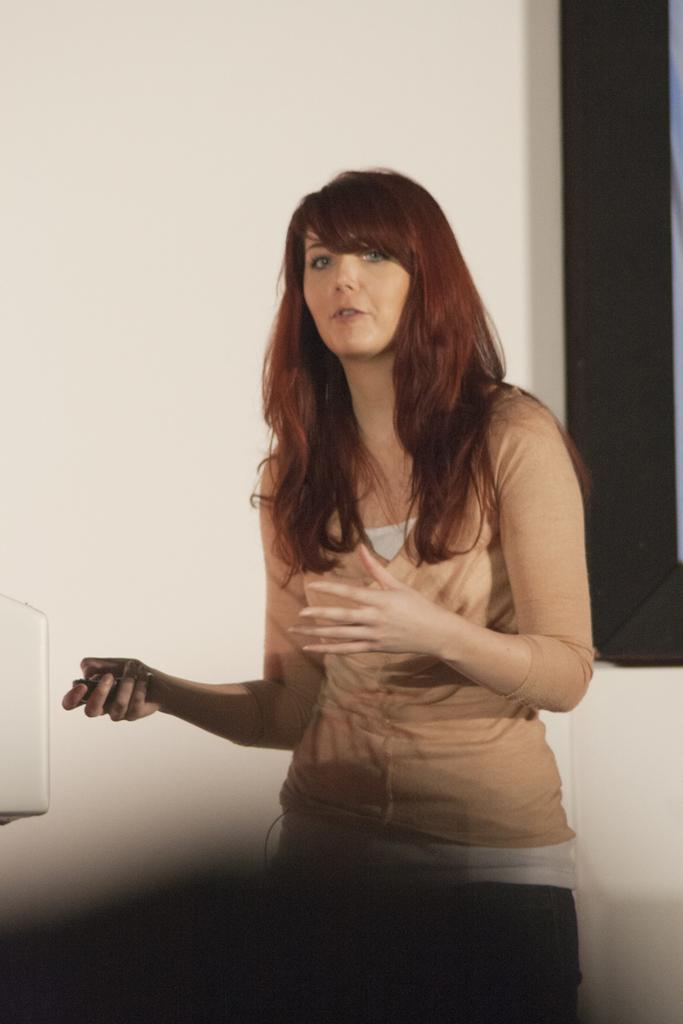What is the woman in the image doing? The woman is standing and talking in the image. What can be seen behind the woman? There is a wall visible behind the woman. What is located behind the woman? There is an object behind the woman. Can you describe the white object on the left side of the image? There is a white object on the left side of the image. What type of lunch is the beggar eating in the image? There is no beggar or lunch present in the image. 